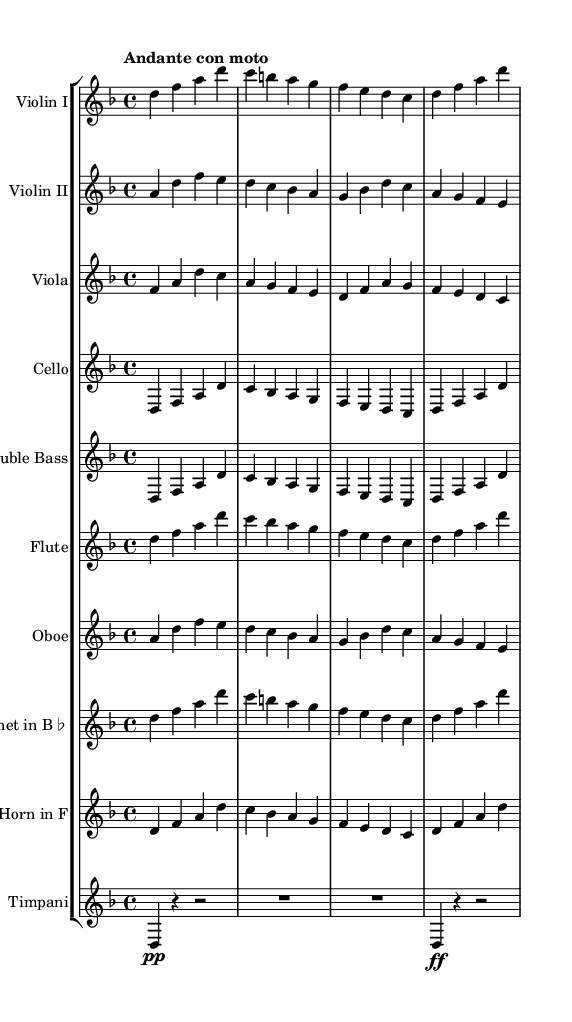What is the key signature of this music? The key signature is D minor, indicated at the beginning of the score where the flats are shown. D minor has one flat (B♭).
Answer: D minor What is the time signature of this music? The time signature is 4/4, shown in the early part of the score by the numbers placed near the beginning. It indicates that there are four beats in each measure.
Answer: 4/4 What is the tempo marking of this composition? The tempo marking is "Andante con moto," which is written in Italian and suggests a moderately fast walking pace.
Answer: Andante con moto How many instruments are in the symphonic arrangement? There are ten instruments listed in the score, including strings and woodwinds, indicated by separate staves for each instrument.
Answer: Ten Which instrument plays the lowest range in this score? The instrument that plays the lowest range is the Double Bass, which typically provides the bass line in orchestral music.
Answer: Double Bass What is the role of the timpani in this piece? The timpani plays a significant role as a rhythmic and harmonic foundation, with specific notes and rests indicated in the score to add emphasis during transitions.
Answer: Rhythmic foundation Which section has the highest pitch in this symphony? The highest pitch in this symphony is usually produced by the Flute, as it often plays in the higher register compared to other instruments listed.
Answer: Flute 